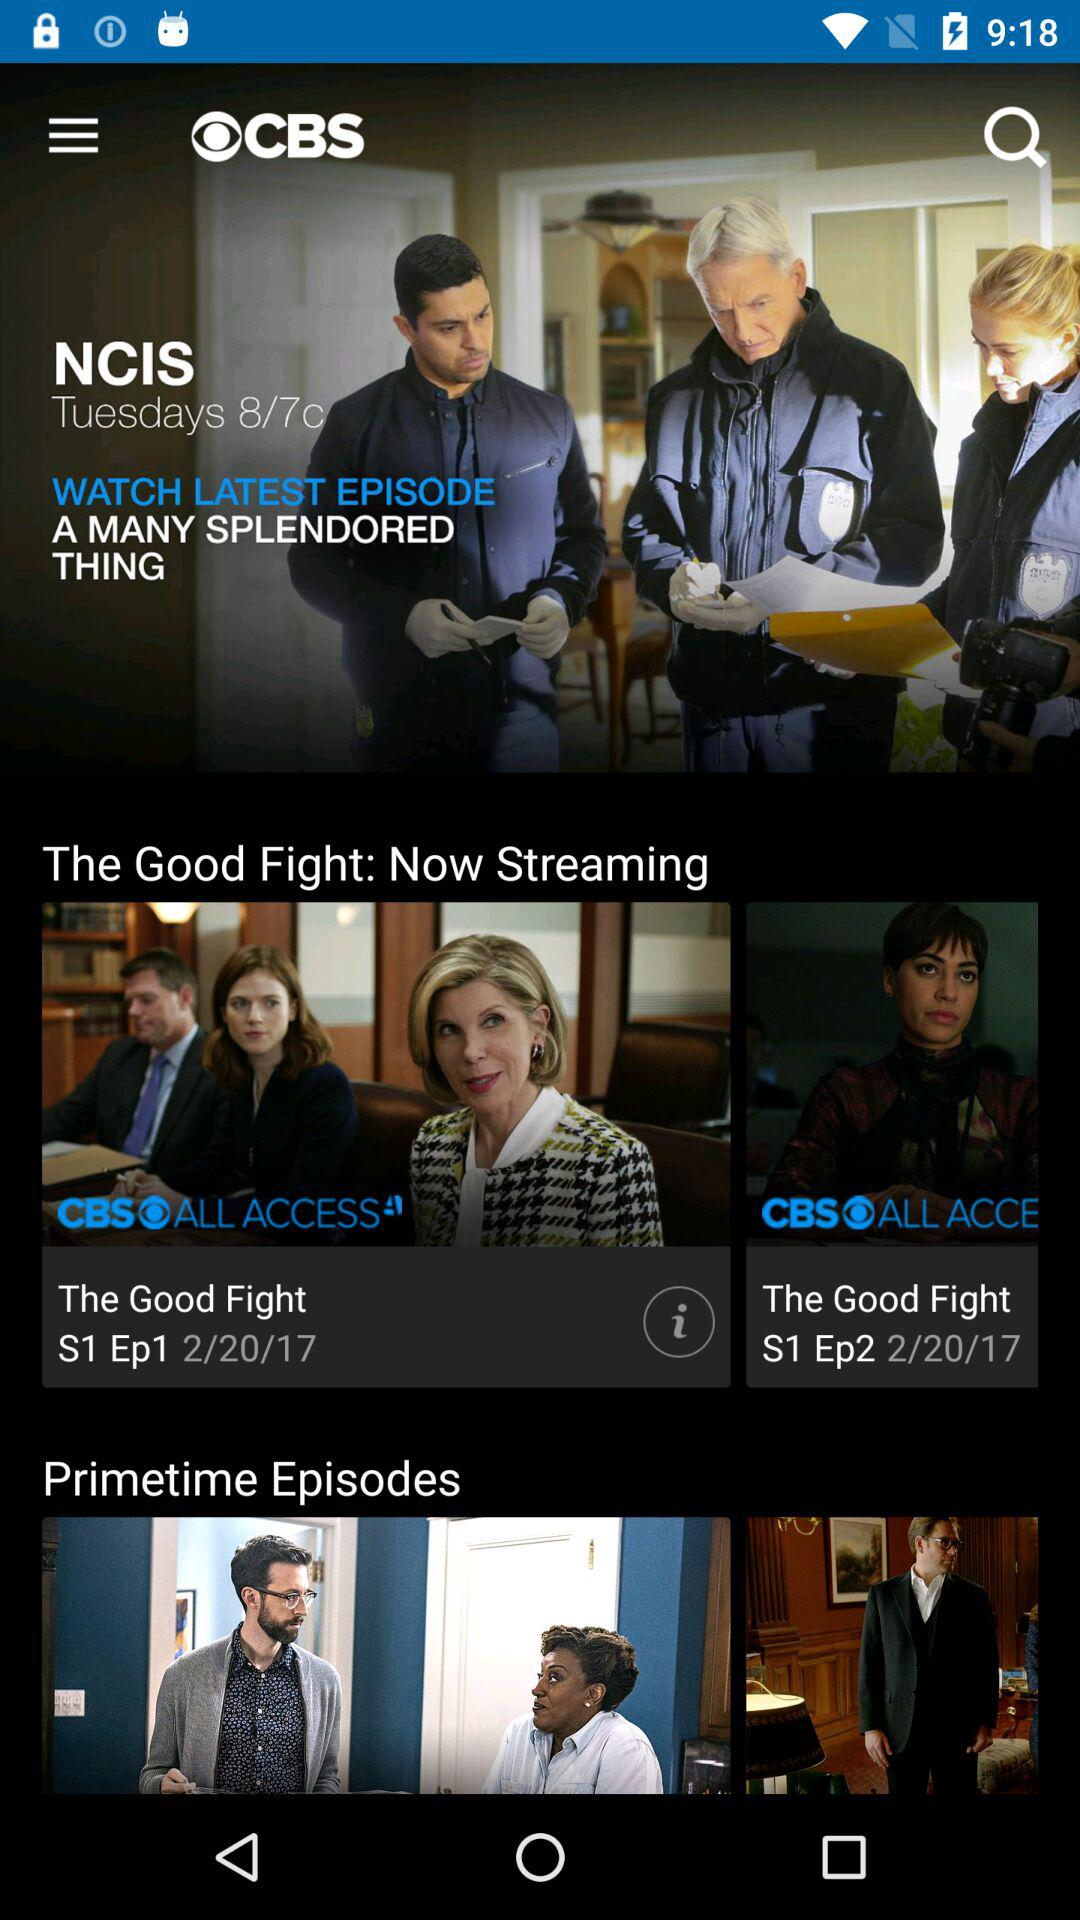When were the terms of use, privacy policy, and video services policy last updated?
When the provided information is insufficient, respond with <no answer>. <no answer> 